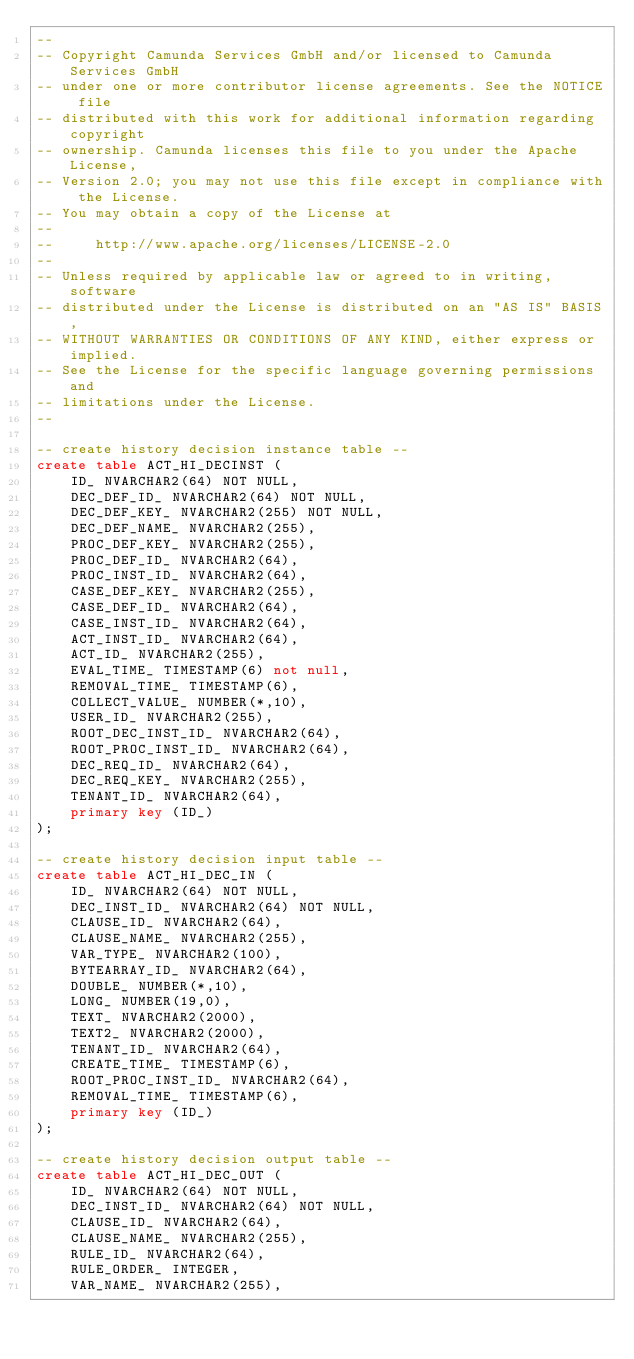Convert code to text. <code><loc_0><loc_0><loc_500><loc_500><_SQL_>--
-- Copyright Camunda Services GmbH and/or licensed to Camunda Services GmbH
-- under one or more contributor license agreements. See the NOTICE file
-- distributed with this work for additional information regarding copyright
-- ownership. Camunda licenses this file to you under the Apache License,
-- Version 2.0; you may not use this file except in compliance with the License.
-- You may obtain a copy of the License at
--
--     http://www.apache.org/licenses/LICENSE-2.0
--
-- Unless required by applicable law or agreed to in writing, software
-- distributed under the License is distributed on an "AS IS" BASIS,
-- WITHOUT WARRANTIES OR CONDITIONS OF ANY KIND, either express or implied.
-- See the License for the specific language governing permissions and
-- limitations under the License.
--

-- create history decision instance table --
create table ACT_HI_DECINST (
    ID_ NVARCHAR2(64) NOT NULL,
    DEC_DEF_ID_ NVARCHAR2(64) NOT NULL,
    DEC_DEF_KEY_ NVARCHAR2(255) NOT NULL,
    DEC_DEF_NAME_ NVARCHAR2(255),
    PROC_DEF_KEY_ NVARCHAR2(255),
    PROC_DEF_ID_ NVARCHAR2(64),
    PROC_INST_ID_ NVARCHAR2(64),
    CASE_DEF_KEY_ NVARCHAR2(255),
    CASE_DEF_ID_ NVARCHAR2(64),
    CASE_INST_ID_ NVARCHAR2(64),
    ACT_INST_ID_ NVARCHAR2(64),
    ACT_ID_ NVARCHAR2(255),
    EVAL_TIME_ TIMESTAMP(6) not null,
    REMOVAL_TIME_ TIMESTAMP(6),
    COLLECT_VALUE_ NUMBER(*,10),
    USER_ID_ NVARCHAR2(255),
    ROOT_DEC_INST_ID_ NVARCHAR2(64),
    ROOT_PROC_INST_ID_ NVARCHAR2(64),
    DEC_REQ_ID_ NVARCHAR2(64),
    DEC_REQ_KEY_ NVARCHAR2(255),
    TENANT_ID_ NVARCHAR2(64),
    primary key (ID_)
);

-- create history decision input table --
create table ACT_HI_DEC_IN (
    ID_ NVARCHAR2(64) NOT NULL,
    DEC_INST_ID_ NVARCHAR2(64) NOT NULL,
    CLAUSE_ID_ NVARCHAR2(64),
    CLAUSE_NAME_ NVARCHAR2(255),
    VAR_TYPE_ NVARCHAR2(100),
    BYTEARRAY_ID_ NVARCHAR2(64),
    DOUBLE_ NUMBER(*,10),
    LONG_ NUMBER(19,0),
    TEXT_ NVARCHAR2(2000),
    TEXT2_ NVARCHAR2(2000),
    TENANT_ID_ NVARCHAR2(64),
    CREATE_TIME_ TIMESTAMP(6),
    ROOT_PROC_INST_ID_ NVARCHAR2(64),
    REMOVAL_TIME_ TIMESTAMP(6),
    primary key (ID_)
);

-- create history decision output table --
create table ACT_HI_DEC_OUT (
    ID_ NVARCHAR2(64) NOT NULL,
    DEC_INST_ID_ NVARCHAR2(64) NOT NULL,
    CLAUSE_ID_ NVARCHAR2(64),
    CLAUSE_NAME_ NVARCHAR2(255),
    RULE_ID_ NVARCHAR2(64),
    RULE_ORDER_ INTEGER,
    VAR_NAME_ NVARCHAR2(255),</code> 